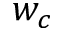<formula> <loc_0><loc_0><loc_500><loc_500>w _ { c }</formula> 